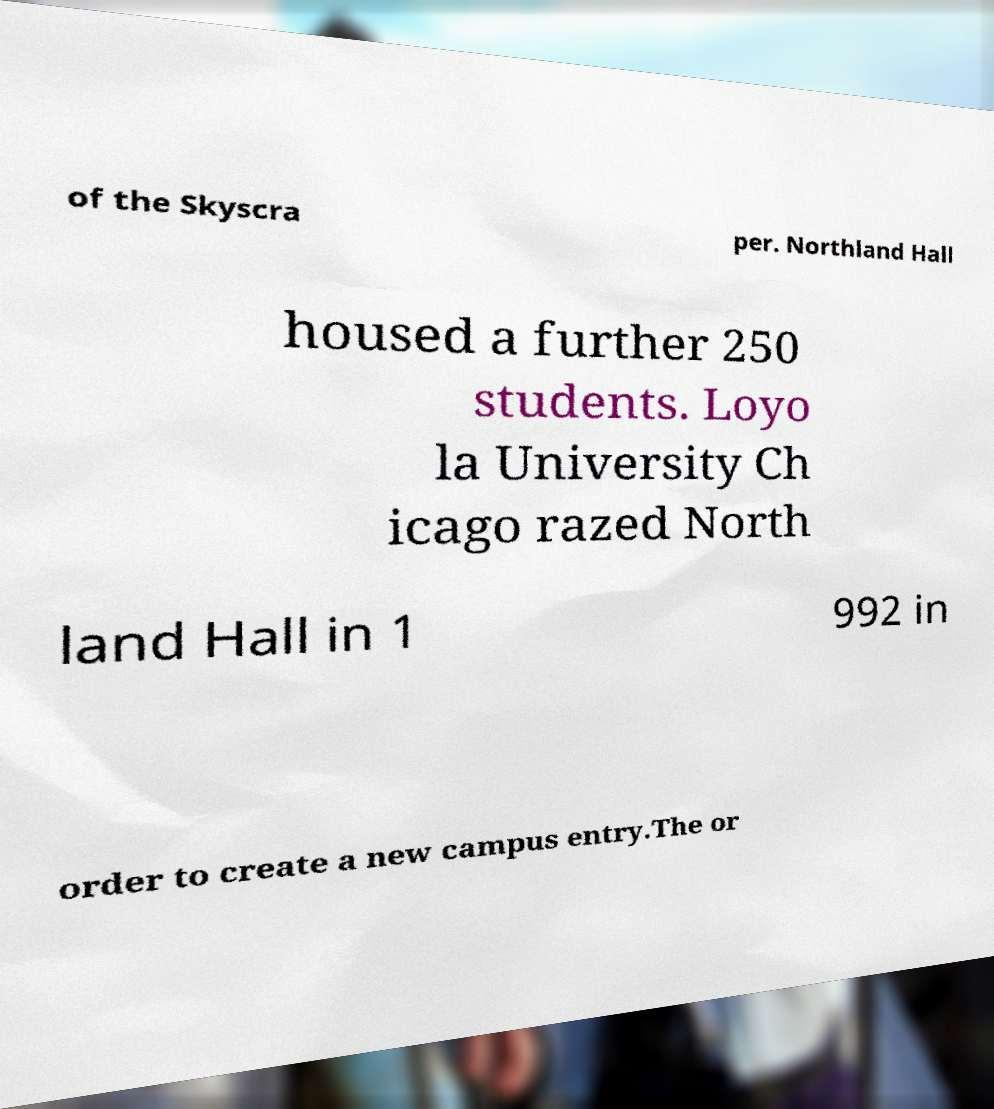Could you assist in decoding the text presented in this image and type it out clearly? of the Skyscra per. Northland Hall housed a further 250 students. Loyo la University Ch icago razed North land Hall in 1 992 in order to create a new campus entry.The or 